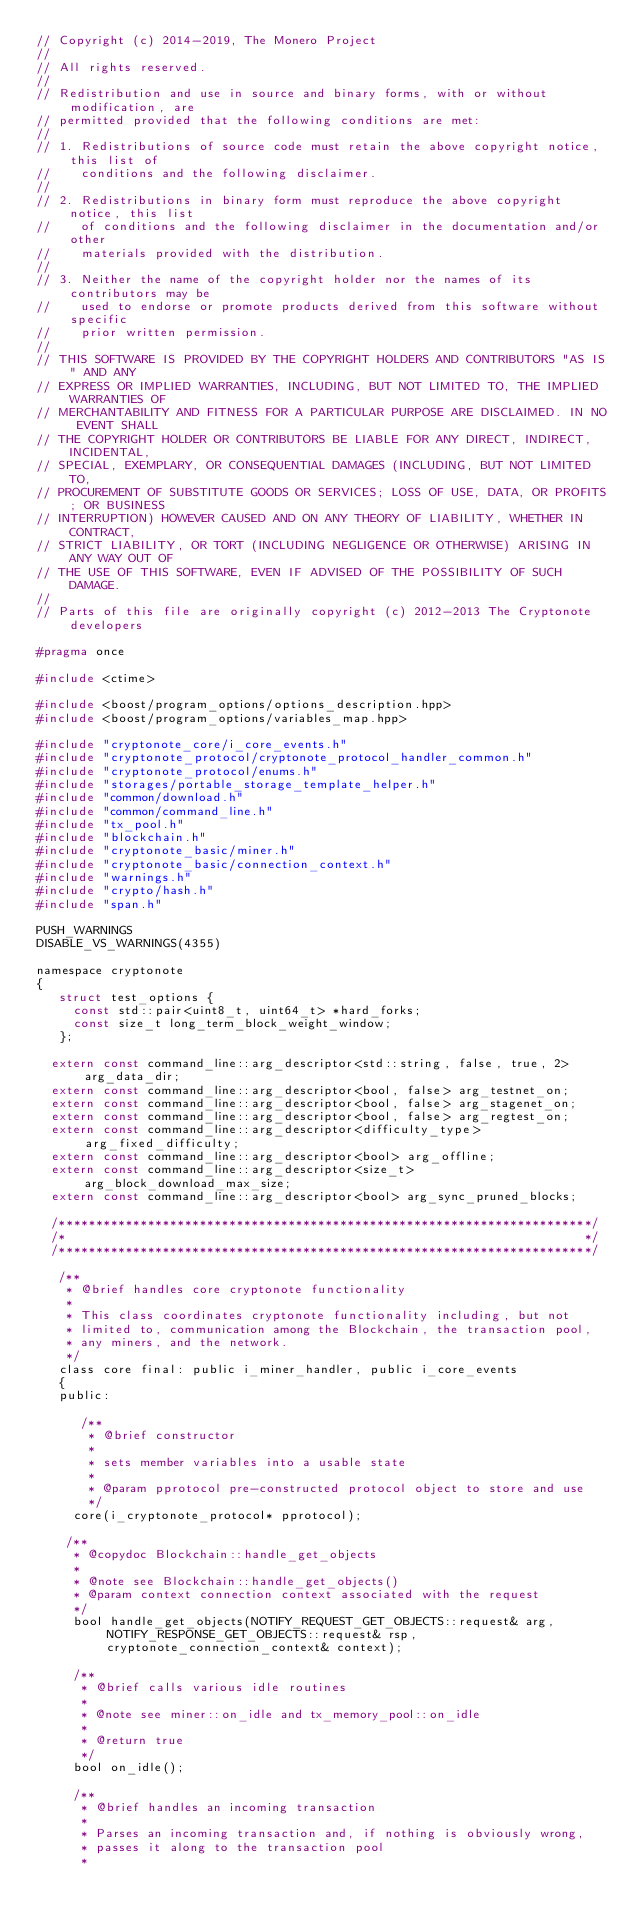<code> <loc_0><loc_0><loc_500><loc_500><_C_>// Copyright (c) 2014-2019, The Monero Project
//
// All rights reserved.
//
// Redistribution and use in source and binary forms, with or without modification, are
// permitted provided that the following conditions are met:
//
// 1. Redistributions of source code must retain the above copyright notice, this list of
//    conditions and the following disclaimer.
//
// 2. Redistributions in binary form must reproduce the above copyright notice, this list
//    of conditions and the following disclaimer in the documentation and/or other
//    materials provided with the distribution.
//
// 3. Neither the name of the copyright holder nor the names of its contributors may be
//    used to endorse or promote products derived from this software without specific
//    prior written permission.
//
// THIS SOFTWARE IS PROVIDED BY THE COPYRIGHT HOLDERS AND CONTRIBUTORS "AS IS" AND ANY
// EXPRESS OR IMPLIED WARRANTIES, INCLUDING, BUT NOT LIMITED TO, THE IMPLIED WARRANTIES OF
// MERCHANTABILITY AND FITNESS FOR A PARTICULAR PURPOSE ARE DISCLAIMED. IN NO EVENT SHALL
// THE COPYRIGHT HOLDER OR CONTRIBUTORS BE LIABLE FOR ANY DIRECT, INDIRECT, INCIDENTAL,
// SPECIAL, EXEMPLARY, OR CONSEQUENTIAL DAMAGES (INCLUDING, BUT NOT LIMITED TO,
// PROCUREMENT OF SUBSTITUTE GOODS OR SERVICES; LOSS OF USE, DATA, OR PROFITS; OR BUSINESS
// INTERRUPTION) HOWEVER CAUSED AND ON ANY THEORY OF LIABILITY, WHETHER IN CONTRACT,
// STRICT LIABILITY, OR TORT (INCLUDING NEGLIGENCE OR OTHERWISE) ARISING IN ANY WAY OUT OF
// THE USE OF THIS SOFTWARE, EVEN IF ADVISED OF THE POSSIBILITY OF SUCH DAMAGE.
//
// Parts of this file are originally copyright (c) 2012-2013 The Cryptonote developers

#pragma once

#include <ctime>

#include <boost/program_options/options_description.hpp>
#include <boost/program_options/variables_map.hpp>

#include "cryptonote_core/i_core_events.h"
#include "cryptonote_protocol/cryptonote_protocol_handler_common.h"
#include "cryptonote_protocol/enums.h"
#include "storages/portable_storage_template_helper.h"
#include "common/download.h"
#include "common/command_line.h"
#include "tx_pool.h"
#include "blockchain.h"
#include "cryptonote_basic/miner.h"
#include "cryptonote_basic/connection_context.h"
#include "warnings.h"
#include "crypto/hash.h"
#include "span.h"

PUSH_WARNINGS
DISABLE_VS_WARNINGS(4355)

namespace cryptonote
{
   struct test_options {
     const std::pair<uint8_t, uint64_t> *hard_forks;
     const size_t long_term_block_weight_window;
   };

  extern const command_line::arg_descriptor<std::string, false, true, 2> arg_data_dir;
  extern const command_line::arg_descriptor<bool, false> arg_testnet_on;
  extern const command_line::arg_descriptor<bool, false> arg_stagenet_on;
  extern const command_line::arg_descriptor<bool, false> arg_regtest_on;
  extern const command_line::arg_descriptor<difficulty_type> arg_fixed_difficulty;
  extern const command_line::arg_descriptor<bool> arg_offline;
  extern const command_line::arg_descriptor<size_t> arg_block_download_max_size;
  extern const command_line::arg_descriptor<bool> arg_sync_pruned_blocks;

  /************************************************************************/
  /*                                                                      */
  /************************************************************************/

   /**
    * @brief handles core cryptonote functionality
    *
    * This class coordinates cryptonote functionality including, but not
    * limited to, communication among the Blockchain, the transaction pool,
    * any miners, and the network.
    */
   class core final: public i_miner_handler, public i_core_events
   {
   public:

      /**
       * @brief constructor
       *
       * sets member variables into a usable state
       *
       * @param pprotocol pre-constructed protocol object to store and use
       */
     core(i_cryptonote_protocol* pprotocol);

    /**
     * @copydoc Blockchain::handle_get_objects
     *
     * @note see Blockchain::handle_get_objects()
     * @param context connection context associated with the request
     */
     bool handle_get_objects(NOTIFY_REQUEST_GET_OBJECTS::request& arg, NOTIFY_RESPONSE_GET_OBJECTS::request& rsp, cryptonote_connection_context& context);

     /**
      * @brief calls various idle routines
      *
      * @note see miner::on_idle and tx_memory_pool::on_idle
      *
      * @return true
      */
     bool on_idle();

     /**
      * @brief handles an incoming transaction
      *
      * Parses an incoming transaction and, if nothing is obviously wrong,
      * passes it along to the transaction pool
      *</code> 